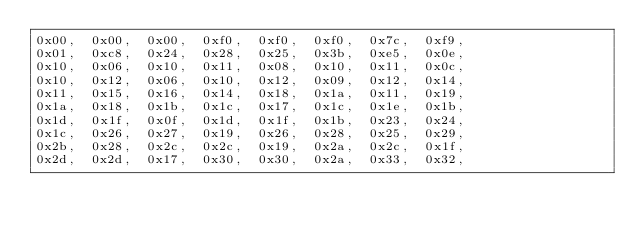<code> <loc_0><loc_0><loc_500><loc_500><_C_>0x00,  0x00,  0x00,  0xf0,  0xf0,  0xf0,  0x7c,  0xf9, 
0x01,  0xc8,  0x24,  0x28,  0x25,  0x3b,  0xe5,  0x0e, 
0x10,  0x06,  0x10,  0x11,  0x08,  0x10,  0x11,  0x0c, 
0x10,  0x12,  0x06,  0x10,  0x12,  0x09,  0x12,  0x14, 
0x11,  0x15,  0x16,  0x14,  0x18,  0x1a,  0x11,  0x19, 
0x1a,  0x18,  0x1b,  0x1c,  0x17,  0x1c,  0x1e,  0x1b, 
0x1d,  0x1f,  0x0f,  0x1d,  0x1f,  0x1b,  0x23,  0x24, 
0x1c,  0x26,  0x27,  0x19,  0x26,  0x28,  0x25,  0x29, 
0x2b,  0x28,  0x2c,  0x2c,  0x19,  0x2a,  0x2c,  0x1f, 
0x2d,  0x2d,  0x17,  0x30,  0x30,  0x2a,  0x33,  0x32, </code> 